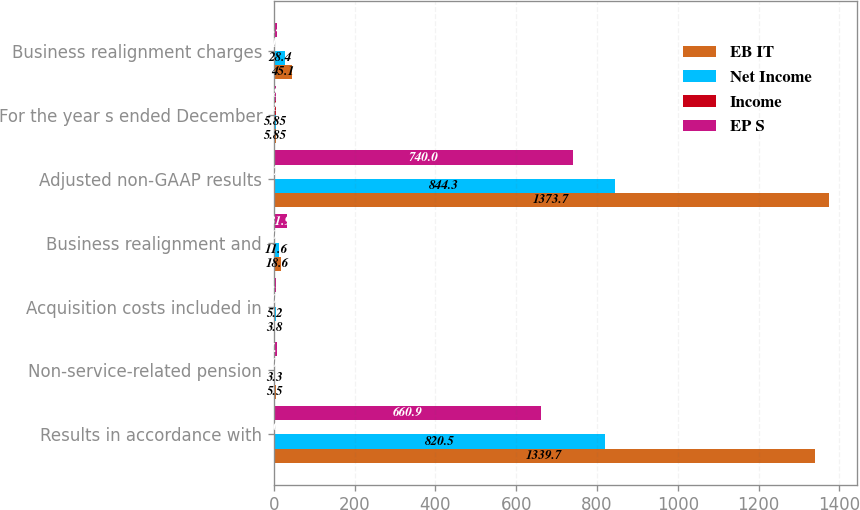Convert chart to OTSL. <chart><loc_0><loc_0><loc_500><loc_500><stacked_bar_chart><ecel><fcel>Results in accordance with<fcel>Non-service-related pension<fcel>Acquisition costs included in<fcel>Business realignment and<fcel>Adjusted non-GAAP results<fcel>For the year s ended December<fcel>Business realignment charges<nl><fcel>EB IT<fcel>1339.7<fcel>5.5<fcel>3.8<fcel>18.6<fcel>1373.7<fcel>5.85<fcel>45.1<nl><fcel>Net Income<fcel>820.5<fcel>3.3<fcel>5.2<fcel>11.6<fcel>844.3<fcel>5.85<fcel>28.4<nl><fcel>Income<fcel>3.61<fcel>0.01<fcel>0.03<fcel>0.05<fcel>3.72<fcel>5.85<fcel>0.12<nl><fcel>EP S<fcel>660.9<fcel>7.4<fcel>6.2<fcel>31.9<fcel>740<fcel>5.85<fcel>8.4<nl></chart> 